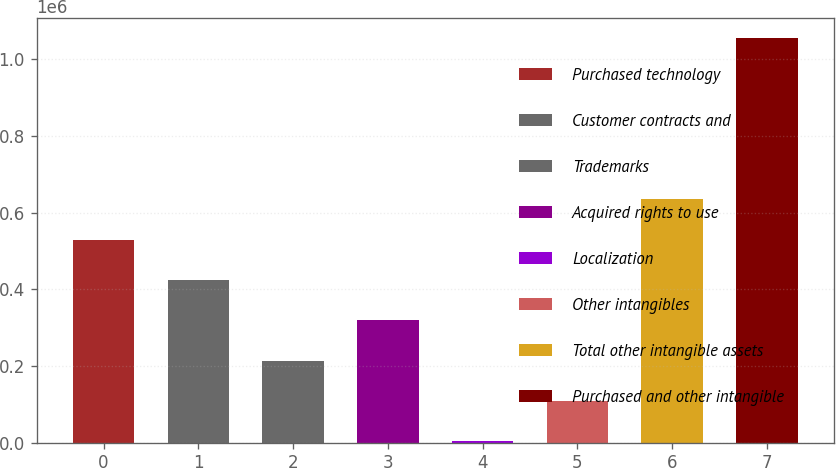Convert chart. <chart><loc_0><loc_0><loc_500><loc_500><bar_chart><fcel>Purchased technology<fcel>Customer contracts and<fcel>Trademarks<fcel>Acquired rights to use<fcel>Localization<fcel>Other intangibles<fcel>Total other intangible assets<fcel>Purchased and other intangible<nl><fcel>529580<fcel>424345<fcel>213874<fcel>319110<fcel>3404<fcel>108639<fcel>634815<fcel>1.05576e+06<nl></chart> 